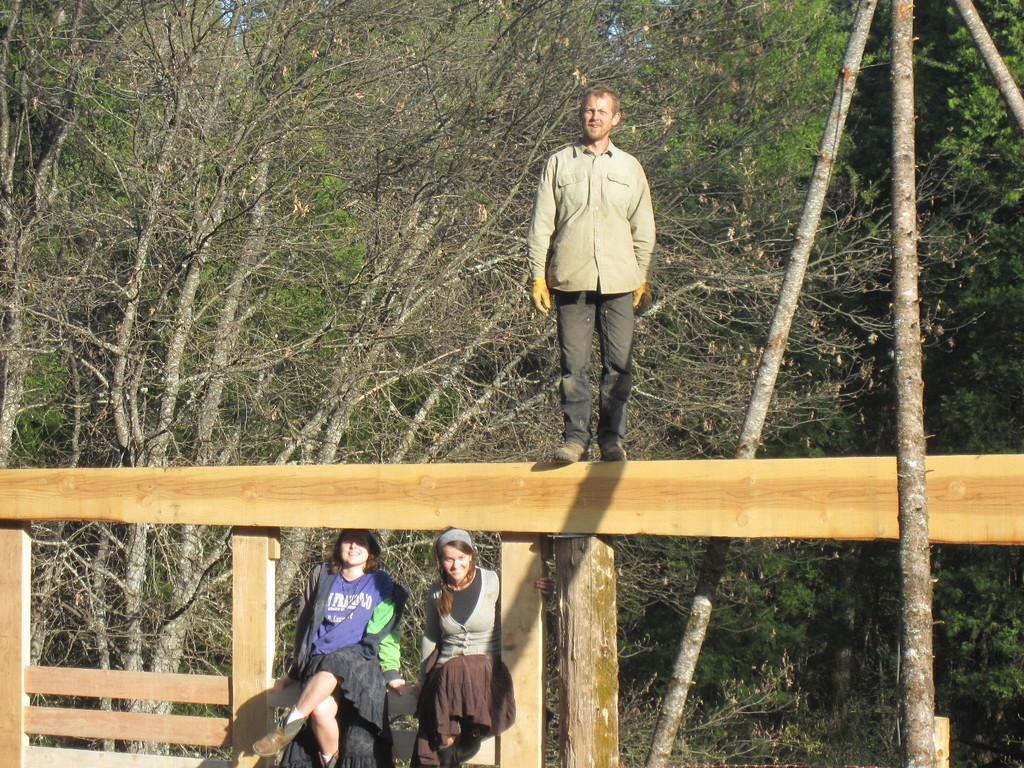Please provide a concise description of this image. In this image we can see these people are sitting and this person is standing on the wooden fence. Here we can see the wooden sticks. In the background, we can see trees. 